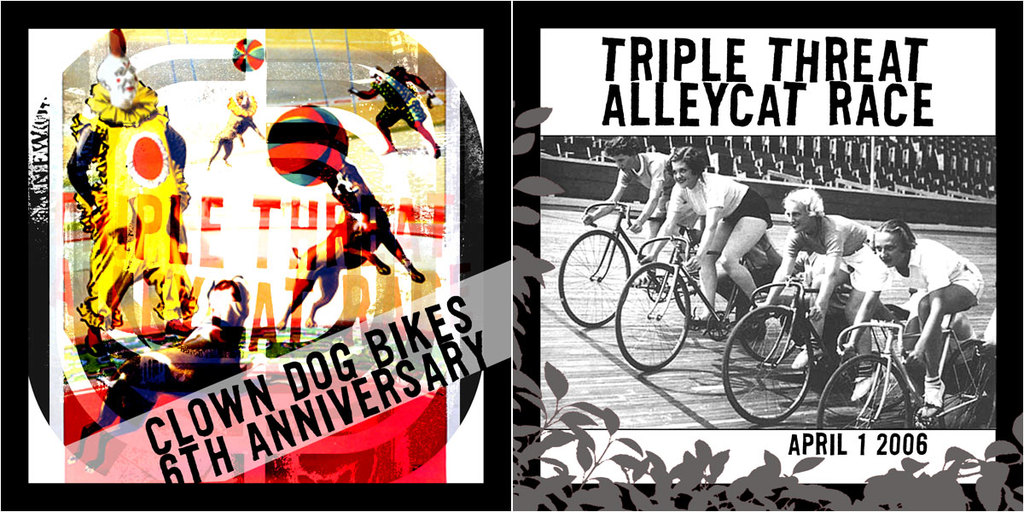Can you describe the theme represented in the left side of the image and how it connects to the event? The left side of the image features colorful and surreal representations of clowns and circus elements, symbolizing the playful and unconventional nature of the Triple Threat Alleycat Race, underlining the event's entertaining and community-driven approach. 